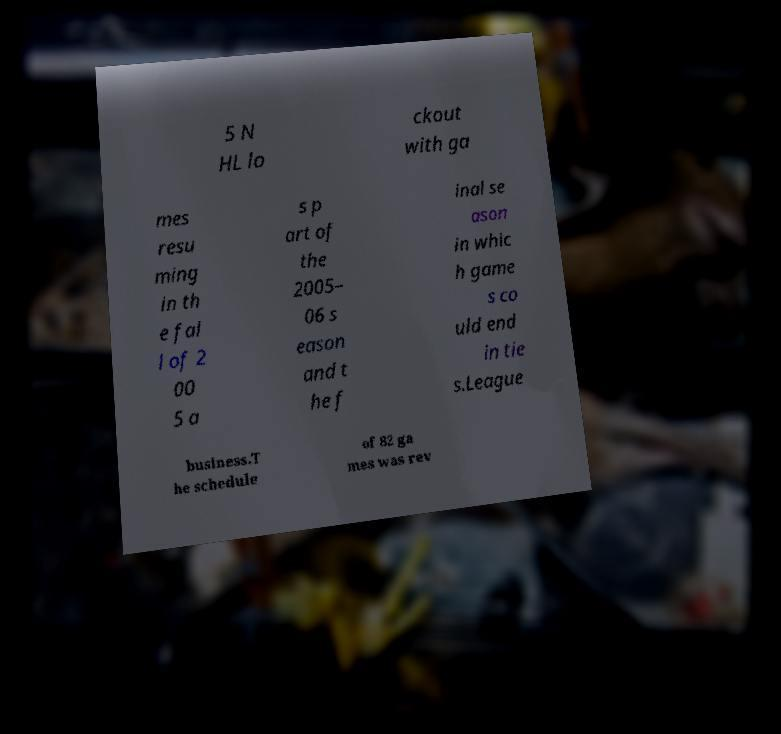What messages or text are displayed in this image? I need them in a readable, typed format. 5 N HL lo ckout with ga mes resu ming in th e fal l of 2 00 5 a s p art of the 2005– 06 s eason and t he f inal se ason in whic h game s co uld end in tie s.League business.T he schedule of 82 ga mes was rev 